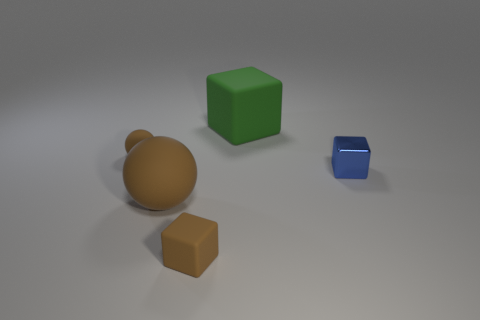Subtract all tiny blocks. How many blocks are left? 1 Add 3 small brown blocks. How many objects exist? 8 Subtract all brown cubes. How many cubes are left? 2 Subtract 0 yellow blocks. How many objects are left? 5 Subtract all balls. How many objects are left? 3 Subtract all purple balls. Subtract all red cylinders. How many balls are left? 2 Subtract all big blue matte spheres. Subtract all tiny brown objects. How many objects are left? 3 Add 2 blue shiny blocks. How many blue shiny blocks are left? 3 Add 5 big brown balls. How many big brown balls exist? 6 